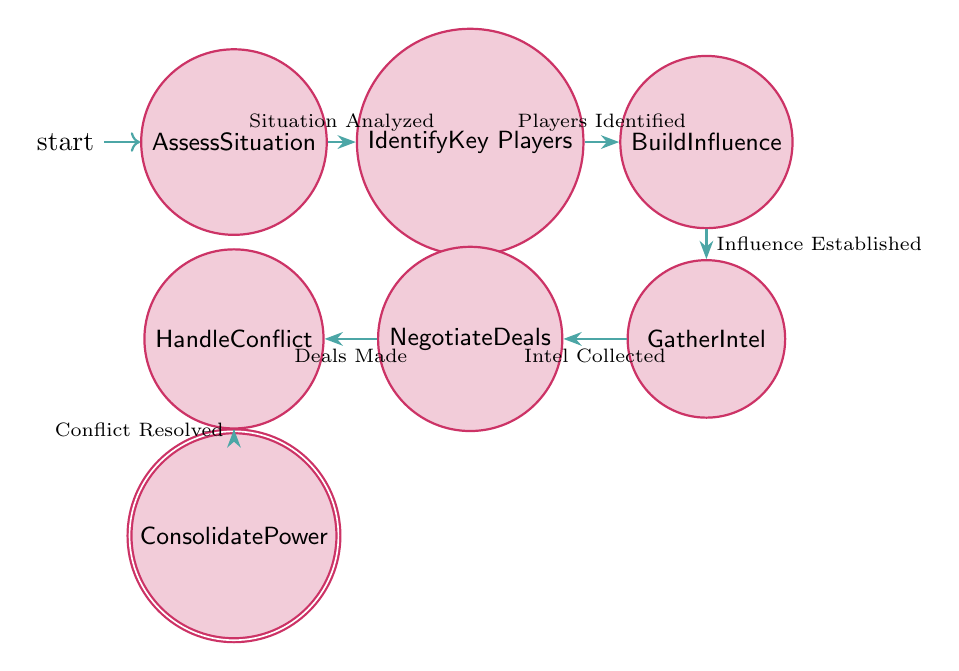What is the initial state of the diagram? The initial state is indicated by the arrow pointing to it. In this diagram, the state "Assess Situation" is the first one, denoting where the process begins.
Answer: Assess Situation How many states are present in the diagram? The states are listed in the data provided, and they include Assess Situation, Identify Key Players, Build Influence, Gather Intel, Negotiate Deals, Handle Conflict, and Consolidate Power. Counting these gives a total of seven states.
Answer: Seven What condition leads from "Build Influence" to "Gather Intel"? The transition from "Build Influence" to "Gather Intel" is based on the condition that influence has been established. This is shown in the transition arrow labeled with this condition.
Answer: Influence Established What is the final state of the diagram? The final state is indicated as an accepting state, which is "Consolidate Power." It is the last node in the flow, showing where the process concludes.
Answer: Consolidate Power Which state requires dealing with conflicts? The state directly related to managing conflicts is "Handle Conflict," as indicated in the diagram's flow. This is a pivotal part of the overall negotiation process to maintain power.
Answer: Handle Conflict What is the transition condition from "Negotiate Deals" to "Handle Conflict"? This transition occurs when deals have been made, demonstrating the importance of successfully negotiating before addressing any conflicts that arise.
Answer: Deals Made What is the relationship between "Gather Intel" and "Negotiate Deals"? The relationship is sequential; "Gather Intel" must occur before "Negotiate Deals." The condition for this transition is that intel must be collected, indicating the necessity of information prior to negotiations.
Answer: Intel Collected Which state follows "Identify Key Players"? The state that follows "Identify Key Players" in the progression of the diagram is "Build Influence," as per the directed path from one state to the next.
Answer: Build Influence 